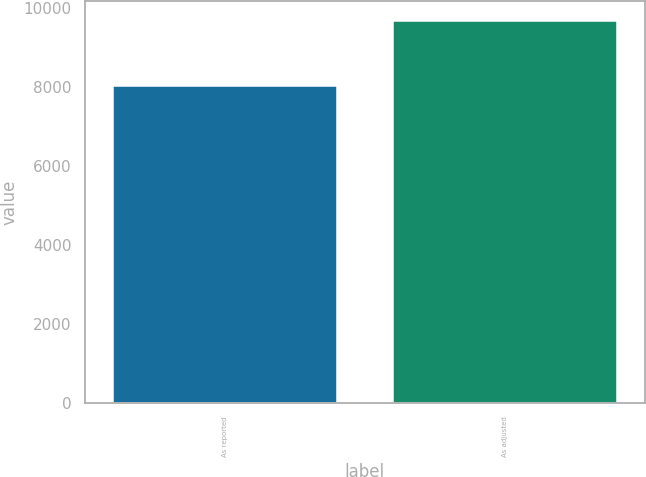<chart> <loc_0><loc_0><loc_500><loc_500><bar_chart><fcel>As reported<fcel>As adjusted<nl><fcel>8012<fcel>9677<nl></chart> 